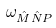Convert formula to latex. <formula><loc_0><loc_0><loc_500><loc_500>\omega _ { \hat { M } \hat { N } P }</formula> 